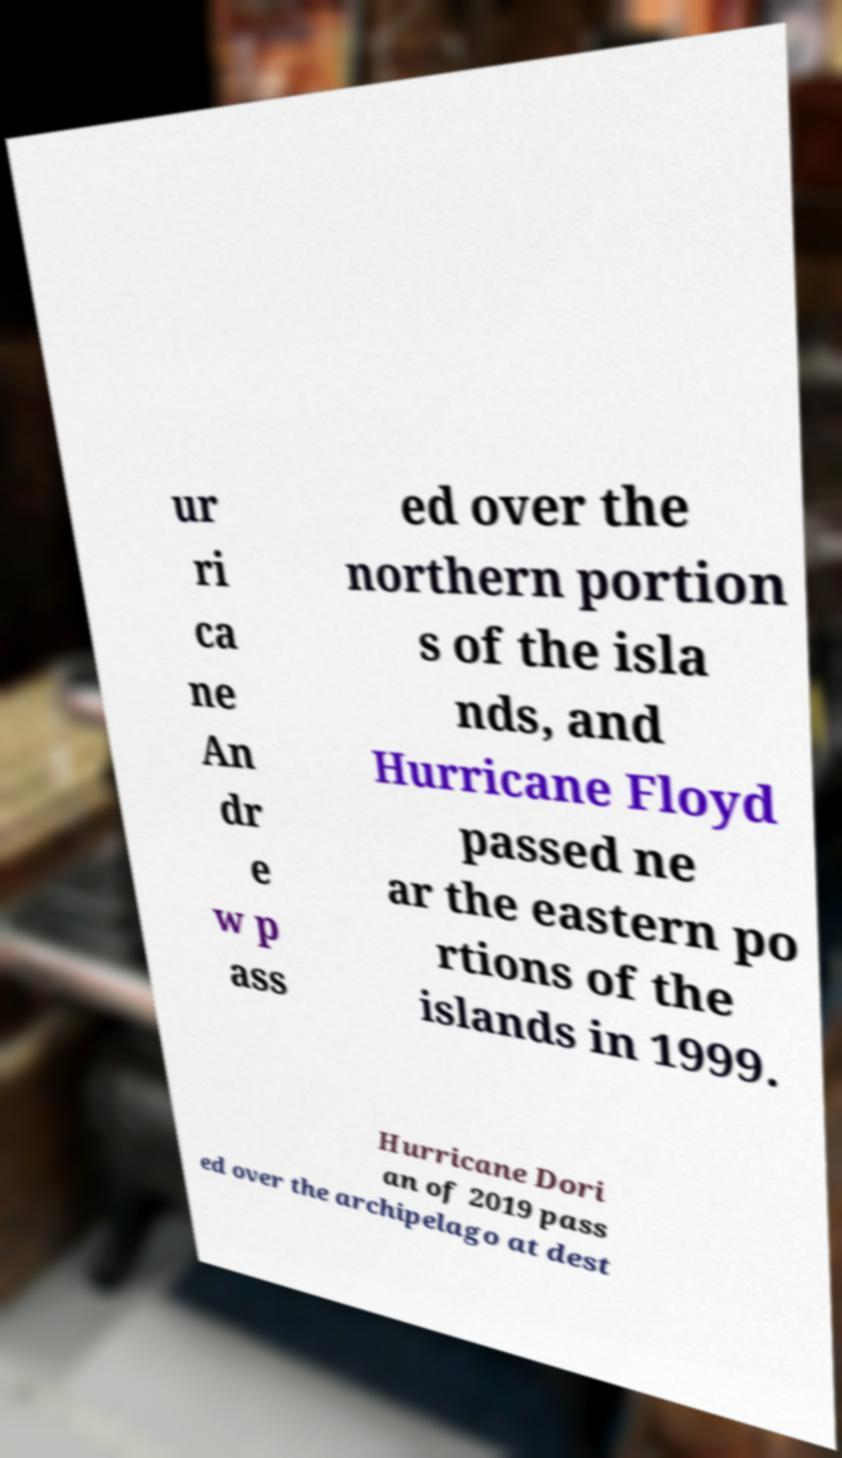Could you extract and type out the text from this image? ur ri ca ne An dr e w p ass ed over the northern portion s of the isla nds, and Hurricane Floyd passed ne ar the eastern po rtions of the islands in 1999. Hurricane Dori an of 2019 pass ed over the archipelago at dest 